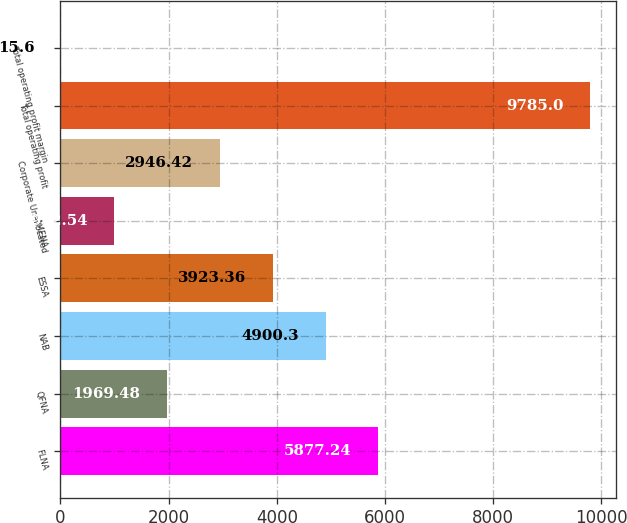Convert chart to OTSL. <chart><loc_0><loc_0><loc_500><loc_500><bar_chart><fcel>FLNA<fcel>QFNA<fcel>NAB<fcel>ESSA<fcel>AMENA<fcel>Corporate Unallocated<fcel>Total operating profit<fcel>Total operating profit margin<nl><fcel>5877.24<fcel>1969.48<fcel>4900.3<fcel>3923.36<fcel>992.54<fcel>2946.42<fcel>9785<fcel>15.6<nl></chart> 